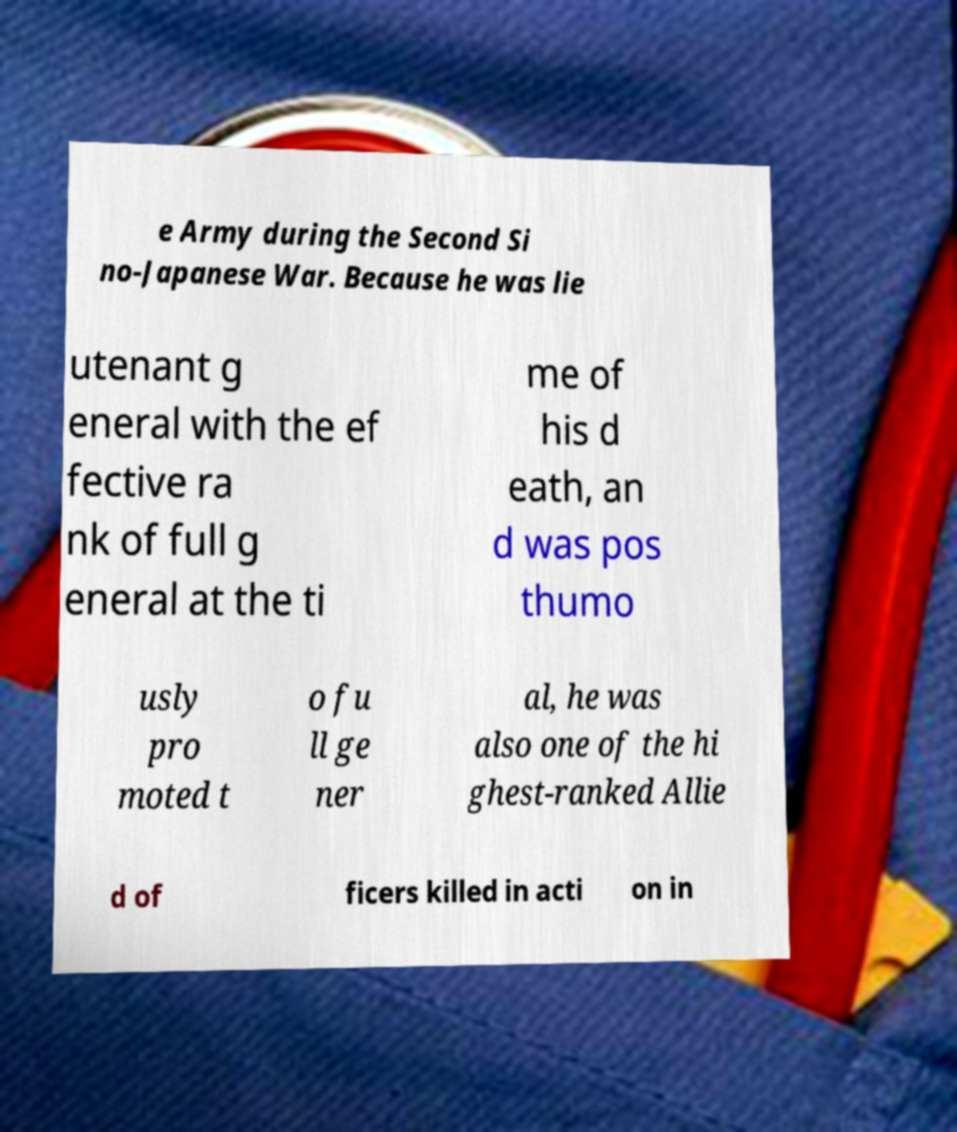Can you read and provide the text displayed in the image?This photo seems to have some interesting text. Can you extract and type it out for me? e Army during the Second Si no-Japanese War. Because he was lie utenant g eneral with the ef fective ra nk of full g eneral at the ti me of his d eath, an d was pos thumo usly pro moted t o fu ll ge ner al, he was also one of the hi ghest-ranked Allie d of ficers killed in acti on in 